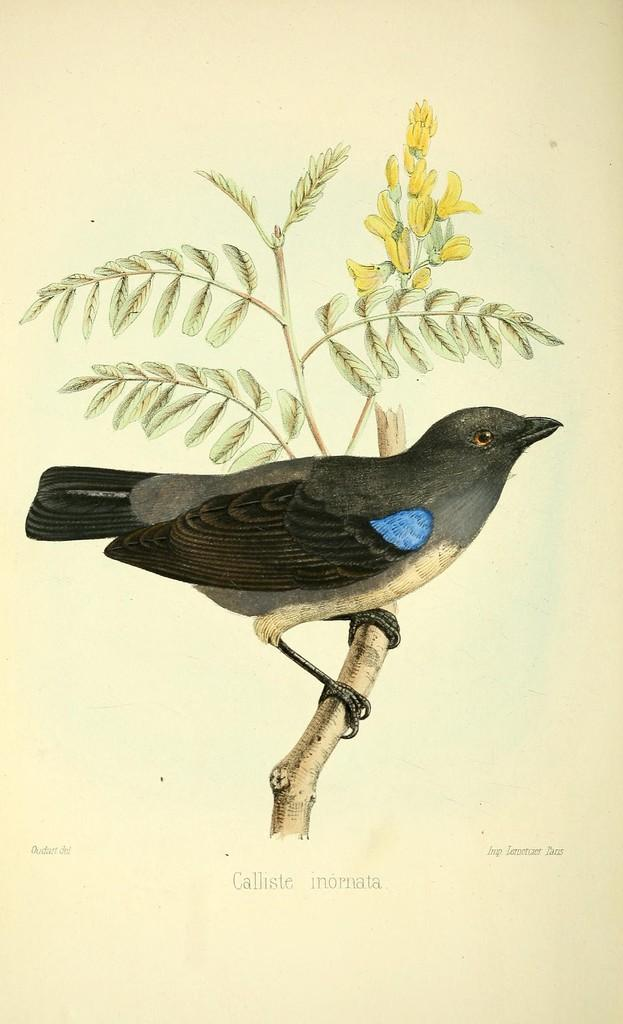What is the main subject of the image? The main subject of the image is a paper. What is depicted on the paper? There is a branch with leaves and yellow flowers on the paper. Is there any living creature on the branch? Yes, there is a black bird sitting on the branch. Is there any text or writing on the paper? Yes, there is writing on the paper. Can you tell me how many wheels are visible on the tiger in the image? There is no tiger present in the image, and therefore no wheels can be observed. 